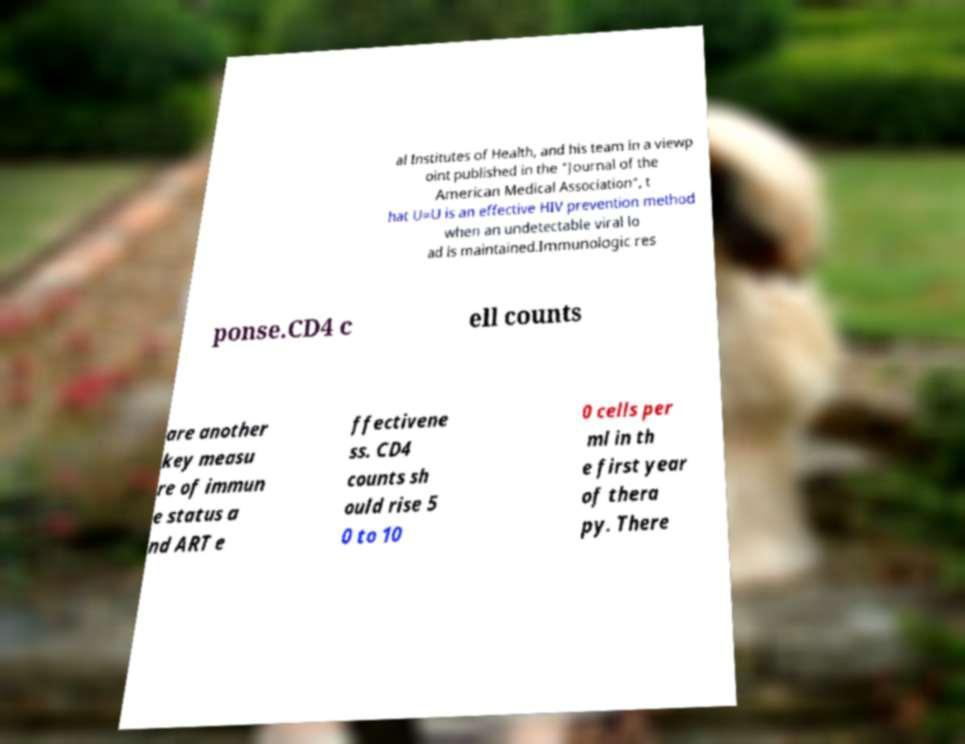Please read and relay the text visible in this image. What does it say? al Institutes of Health, and his team in a viewp oint published in the "Journal of the American Medical Association", t hat U=U is an effective HIV prevention method when an undetectable viral lo ad is maintained.Immunologic res ponse.CD4 c ell counts are another key measu re of immun e status a nd ART e ffectivene ss. CD4 counts sh ould rise 5 0 to 10 0 cells per ml in th e first year of thera py. There 